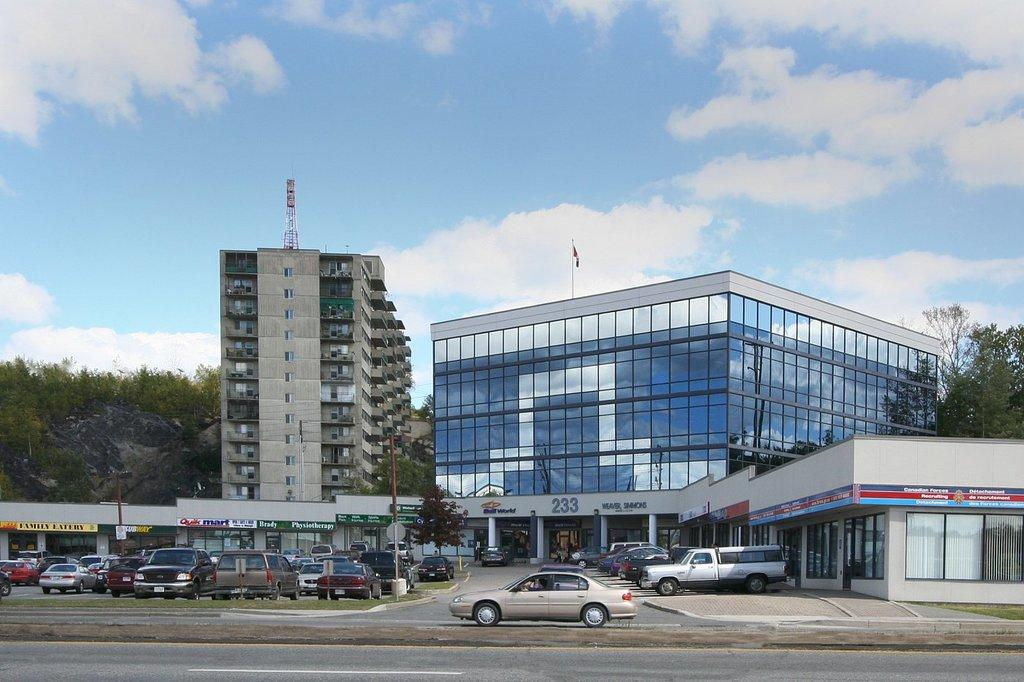What type of structures can be seen in the image? There are buildings in the image. What else is visible besides the buildings? There are vehicles, trees, windows, pillars, mountains, and the sky visible in the image. Can you describe the sky in the image? The sky is visible in the background of the image, and clouds are present in the sky. What type of lace can be seen on the tiger in the image? There is no tiger or lace present in the image. How many leaves are visible on the trees in the image? The image does not provide a close enough view to count individual leaves on the trees. 